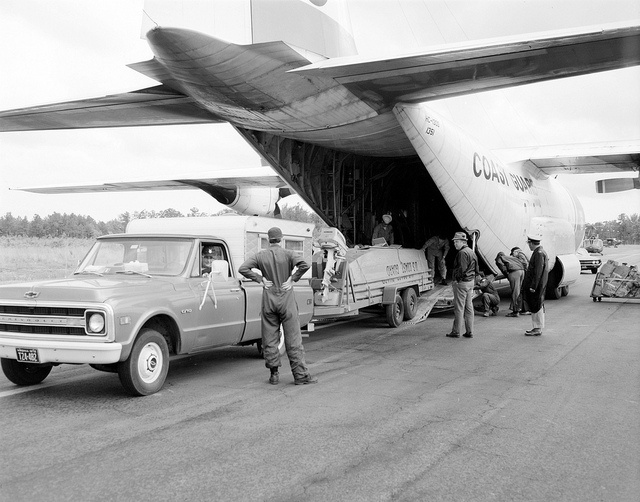Describe the objects in this image and their specific colors. I can see airplane in white, lightgray, black, gray, and darkgray tones, truck in white, lightgray, darkgray, gray, and black tones, people in white, gray, darkgray, black, and lightgray tones, people in white, gray, black, darkgray, and lightgray tones, and people in white, black, gray, darkgray, and lightgray tones in this image. 